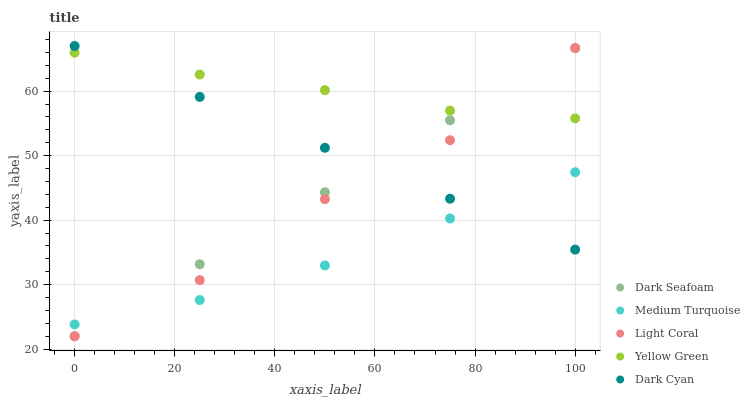Does Medium Turquoise have the minimum area under the curve?
Answer yes or no. Yes. Does Yellow Green have the maximum area under the curve?
Answer yes or no. Yes. Does Dark Cyan have the minimum area under the curve?
Answer yes or no. No. Does Dark Cyan have the maximum area under the curve?
Answer yes or no. No. Is Dark Seafoam the smoothest?
Answer yes or no. Yes. Is Light Coral the roughest?
Answer yes or no. Yes. Is Dark Cyan the smoothest?
Answer yes or no. No. Is Dark Cyan the roughest?
Answer yes or no. No. Does Light Coral have the lowest value?
Answer yes or no. Yes. Does Dark Cyan have the lowest value?
Answer yes or no. No. Does Dark Cyan have the highest value?
Answer yes or no. Yes. Does Dark Seafoam have the highest value?
Answer yes or no. No. Is Medium Turquoise less than Yellow Green?
Answer yes or no. Yes. Is Yellow Green greater than Medium Turquoise?
Answer yes or no. Yes. Does Light Coral intersect Dark Cyan?
Answer yes or no. Yes. Is Light Coral less than Dark Cyan?
Answer yes or no. No. Is Light Coral greater than Dark Cyan?
Answer yes or no. No. Does Medium Turquoise intersect Yellow Green?
Answer yes or no. No. 